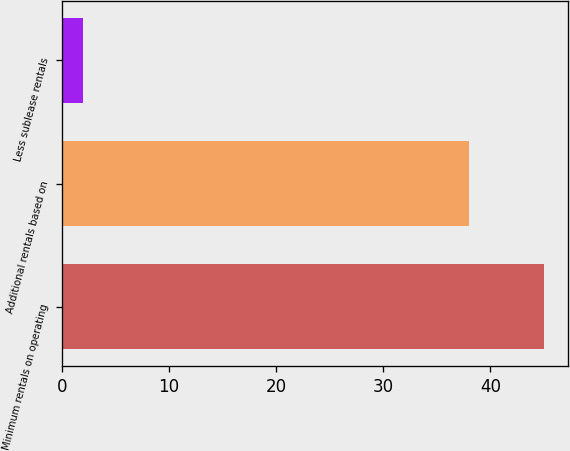Convert chart. <chart><loc_0><loc_0><loc_500><loc_500><bar_chart><fcel>Minimum rentals on operating<fcel>Additional rentals based on<fcel>Less sublease rentals<nl><fcel>45<fcel>38<fcel>2<nl></chart> 